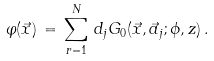<formula> <loc_0><loc_0><loc_500><loc_500>\varphi ( \vec { x } ) \, = \, \sum _ { r = 1 } ^ { N } \, d _ { j } G _ { 0 } ( \vec { x } , \vec { a } _ { j } ; \phi , z ) \, .</formula> 